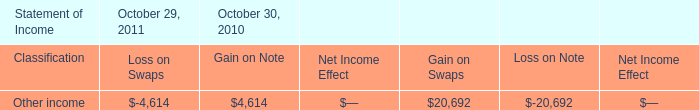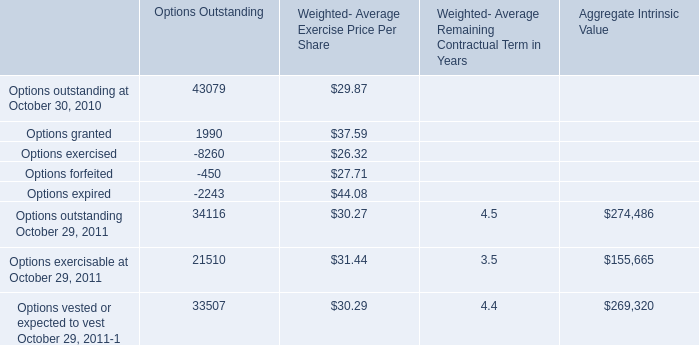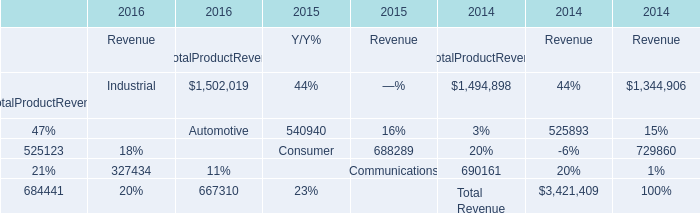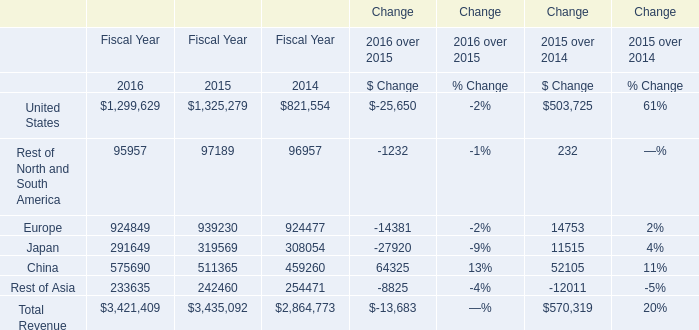what is the yearly interest payment related to the $ 375 million notional amount included in the swap terms? 
Computations: (375 * 5.0%)
Answer: 18.75. 